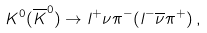Convert formula to latex. <formula><loc_0><loc_0><loc_500><loc_500>K ^ { 0 } ( \overline { K } ^ { 0 } ) \rightarrow l ^ { + } \nu \pi ^ { - } ( l ^ { - } \overline { \nu } \pi ^ { + } ) \, ,</formula> 